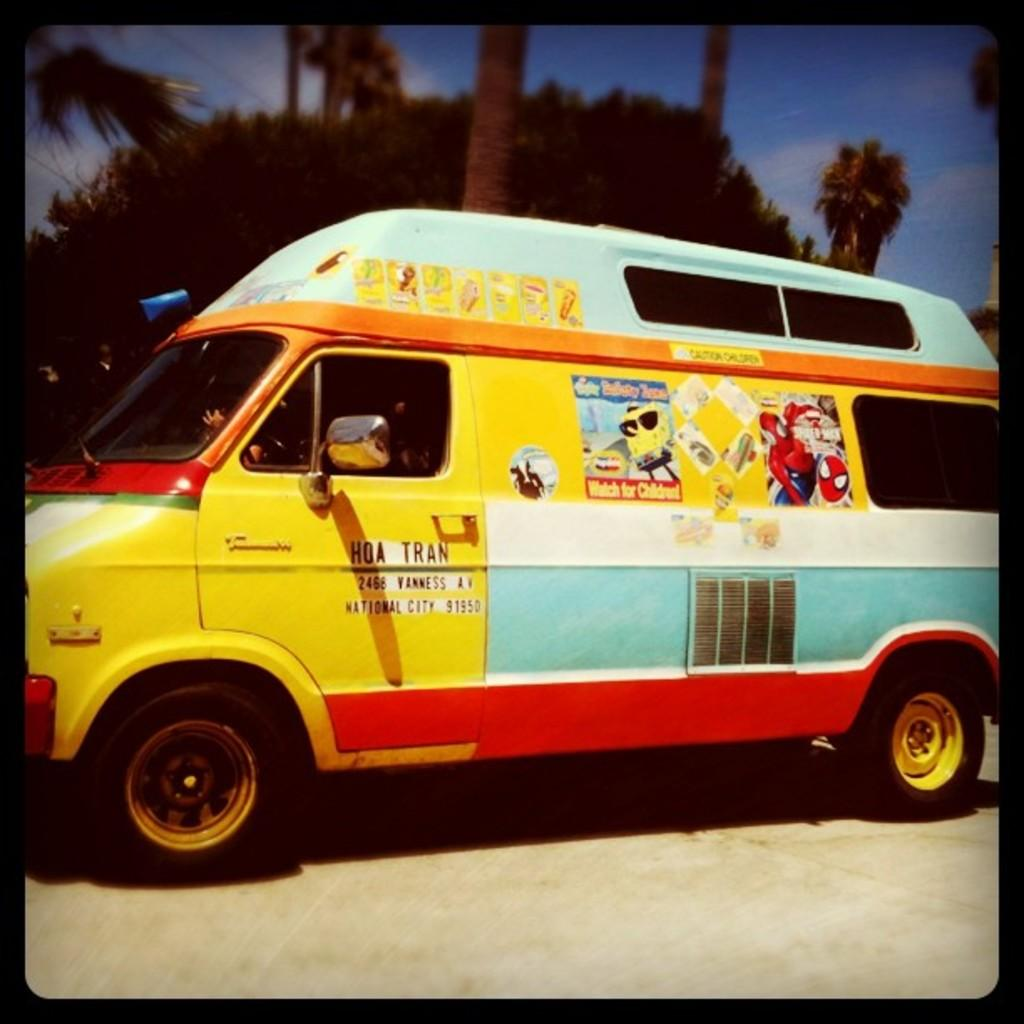What is the main subject of the image? There is a vehicle in the image. Where is the vehicle located? The vehicle is on the road. What can be seen in the background of the image? There are trees and sky visible in the background of the image. What is the condition of the sky in the image? There are clouds in the sky. What type of knee can be seen supporting the vehicle in the image? There is no knee present in the image; the vehicle is on the road, not supported by a knee. What is the quiver used for in the image? There is no quiver present in the image. 